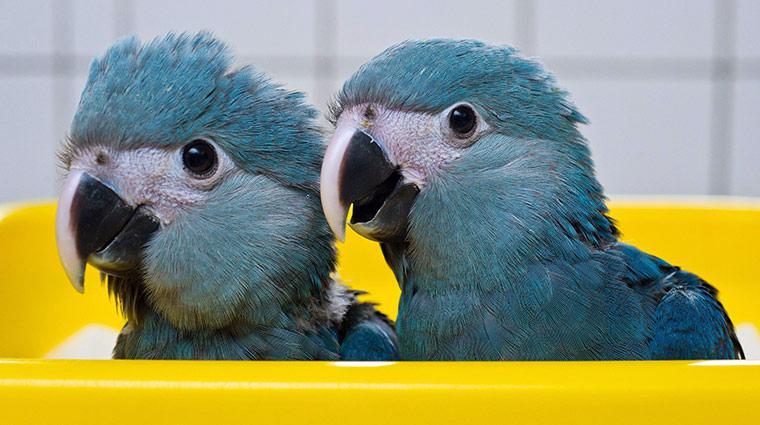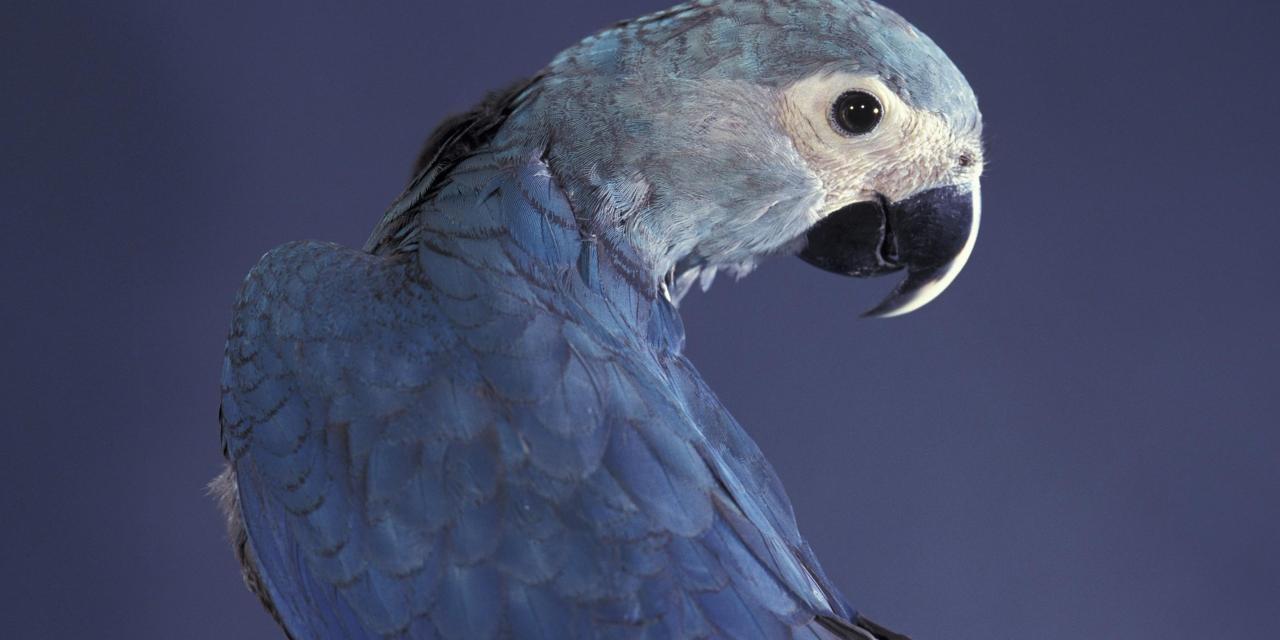The first image is the image on the left, the second image is the image on the right. Considering the images on both sides, is "All of the birds sit on a branch with a blue background behind them." valid? Answer yes or no. No. The first image is the image on the left, the second image is the image on the right. Assess this claim about the two images: "There are two birds in the left image and one bird in the right image.". Correct or not? Answer yes or no. Yes. The first image is the image on the left, the second image is the image on the right. For the images shown, is this caption "All blue parrots have white faces with black eyes and beak that is black and white." true? Answer yes or no. Yes. 